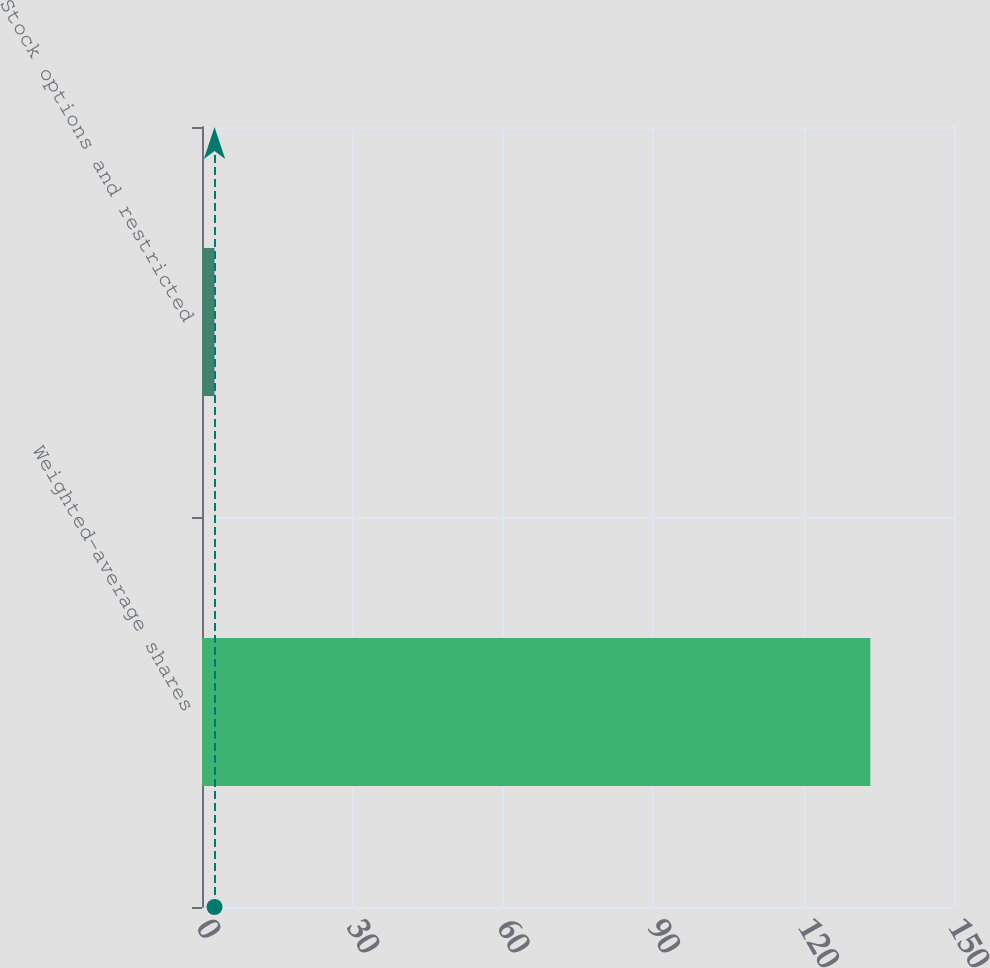Convert chart to OTSL. <chart><loc_0><loc_0><loc_500><loc_500><bar_chart><fcel>Weighted-average shares<fcel>Stock options and restricted<nl><fcel>133.32<fcel>2.5<nl></chart> 